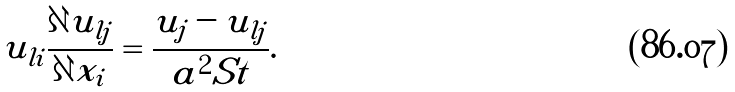<formula> <loc_0><loc_0><loc_500><loc_500>u _ { l i } \frac { \partial u _ { l j } } { \partial x _ { i } } = \frac { u _ { j } - u _ { l j } } { a ^ { 2 } S t } .</formula> 